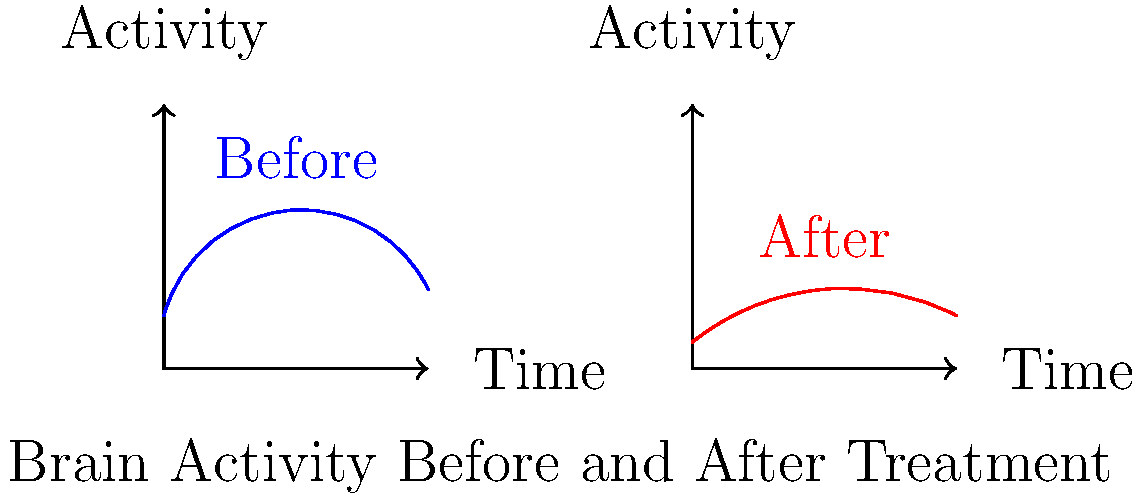Examine the brain activity graphs before and after a psychiatric treatment. What does the change in the curve pattern suggest about the effectiveness of the treatment in managing the patient's condition? To analyze the effectiveness of the treatment, we need to compare the two graphs:

1. Before treatment (blue curve):
   - The curve shows high fluctuations in brain activity.
   - It reaches a peak around the middle of the time period.
   - The overall activity level is higher.

2. After treatment (red curve):
   - The curve shows much less fluctuation in brain activity.
   - The peak is lower and less pronounced.
   - The overall activity level is lower and more consistent.

3. Interpretation:
   - Reduced fluctuations suggest improved stability in brain function.
   - Lower overall activity may indicate a reduction in overactive brain regions.
   - More consistent activity over time implies better regulation of neural processes.

4. Clinical significance:
   - In many psychiatric conditions, excessive or erratic brain activity is associated with symptoms.
   - A more stable, lower-level activity pattern often correlates with symptom improvement.

5. Conclusion:
   The treatment appears to be effective in stabilizing brain activity and potentially reducing symptoms associated with overactive or unstable neural processes.
Answer: The treatment is effective, stabilizing brain activity and potentially reducing symptoms. 